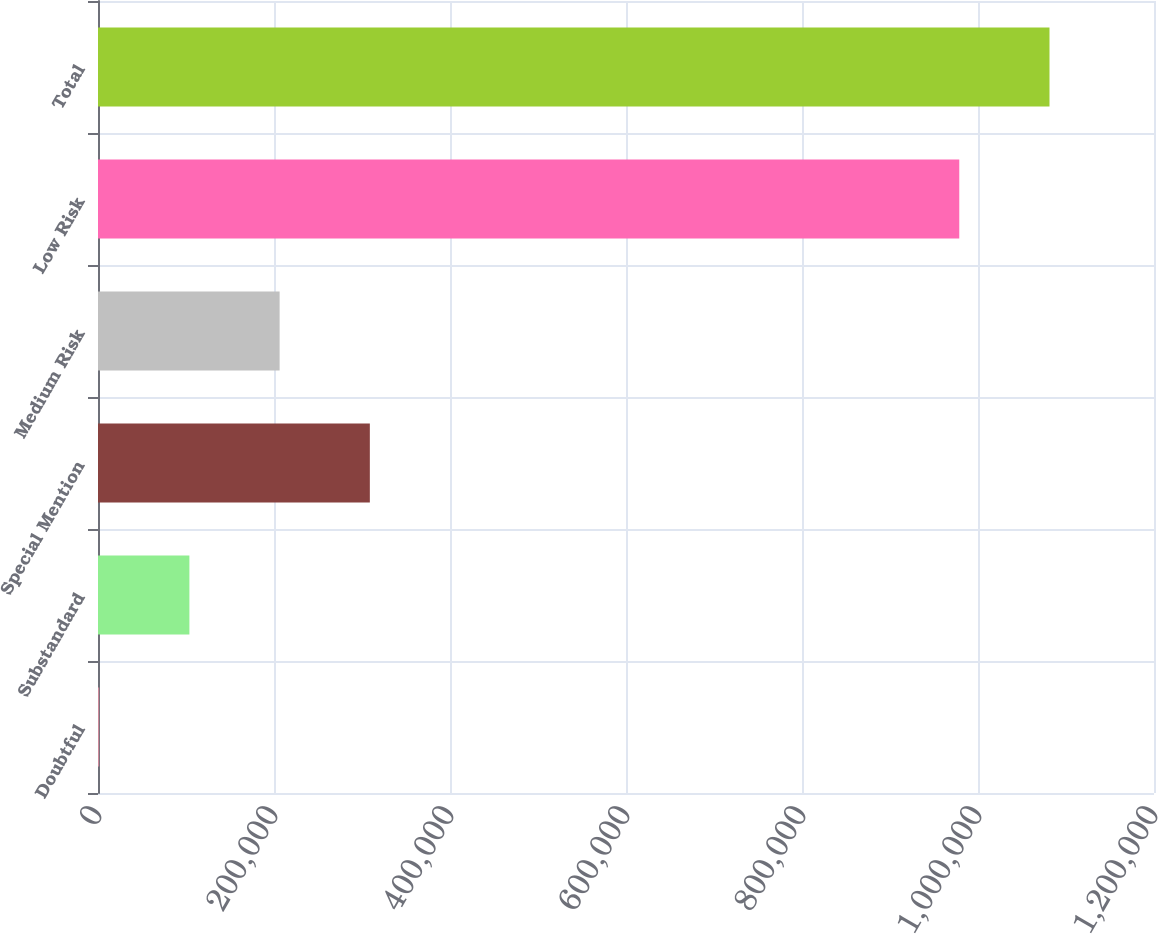Convert chart to OTSL. <chart><loc_0><loc_0><loc_500><loc_500><bar_chart><fcel>Doubtful<fcel>Substandard<fcel>Special Mention<fcel>Medium Risk<fcel>Low Risk<fcel>Total<nl><fcel>1333<fcel>103859<fcel>308910<fcel>206384<fcel>978712<fcel>1.08124e+06<nl></chart> 